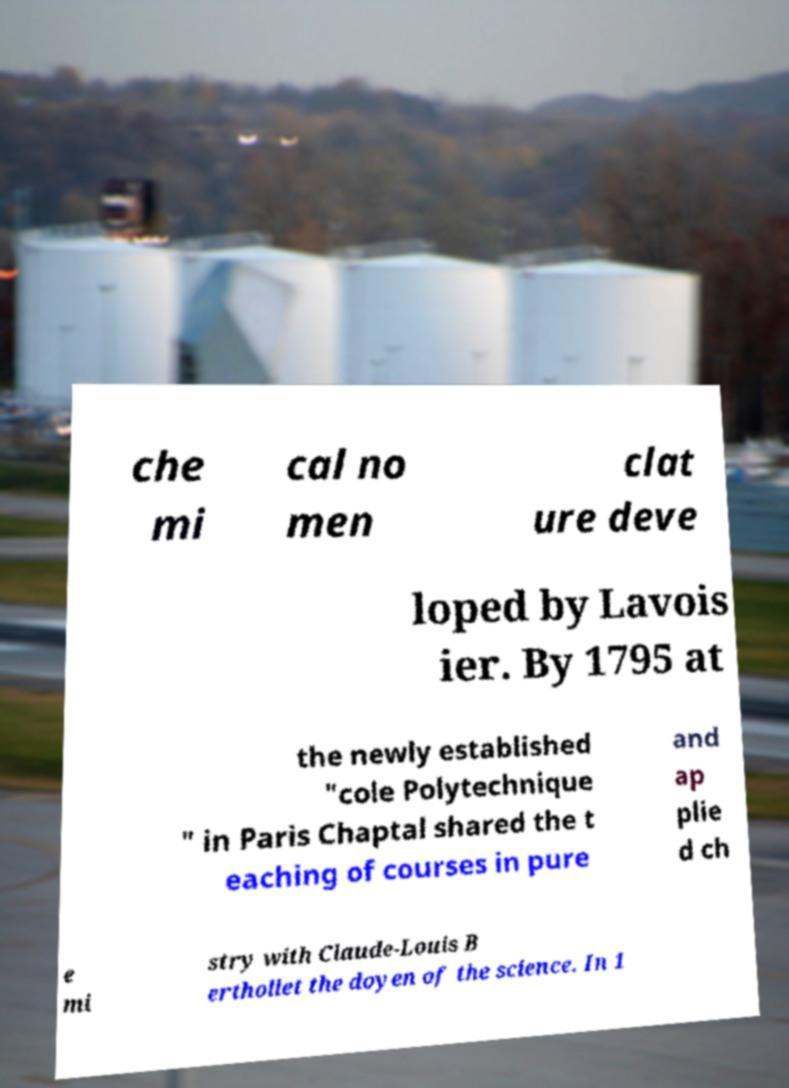For documentation purposes, I need the text within this image transcribed. Could you provide that? che mi cal no men clat ure deve loped by Lavois ier. By 1795 at the newly established "cole Polytechnique " in Paris Chaptal shared the t eaching of courses in pure and ap plie d ch e mi stry with Claude-Louis B erthollet the doyen of the science. In 1 